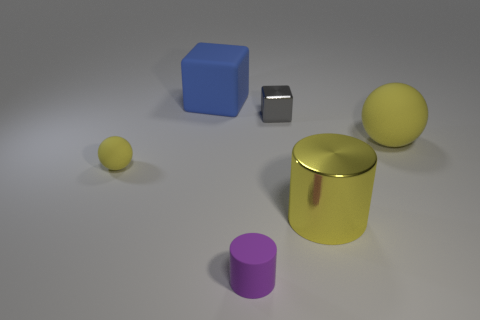Could you tell me which objects in the image would likely weigh more based on their sizes and potential materials? Based on their sizes and assuming standard densities, the large yellow cylinder and the blue cube would likely weigh more than the other objects. The small metallic cube might also be quite heavy relative to its size if it's made from a dense metal. 